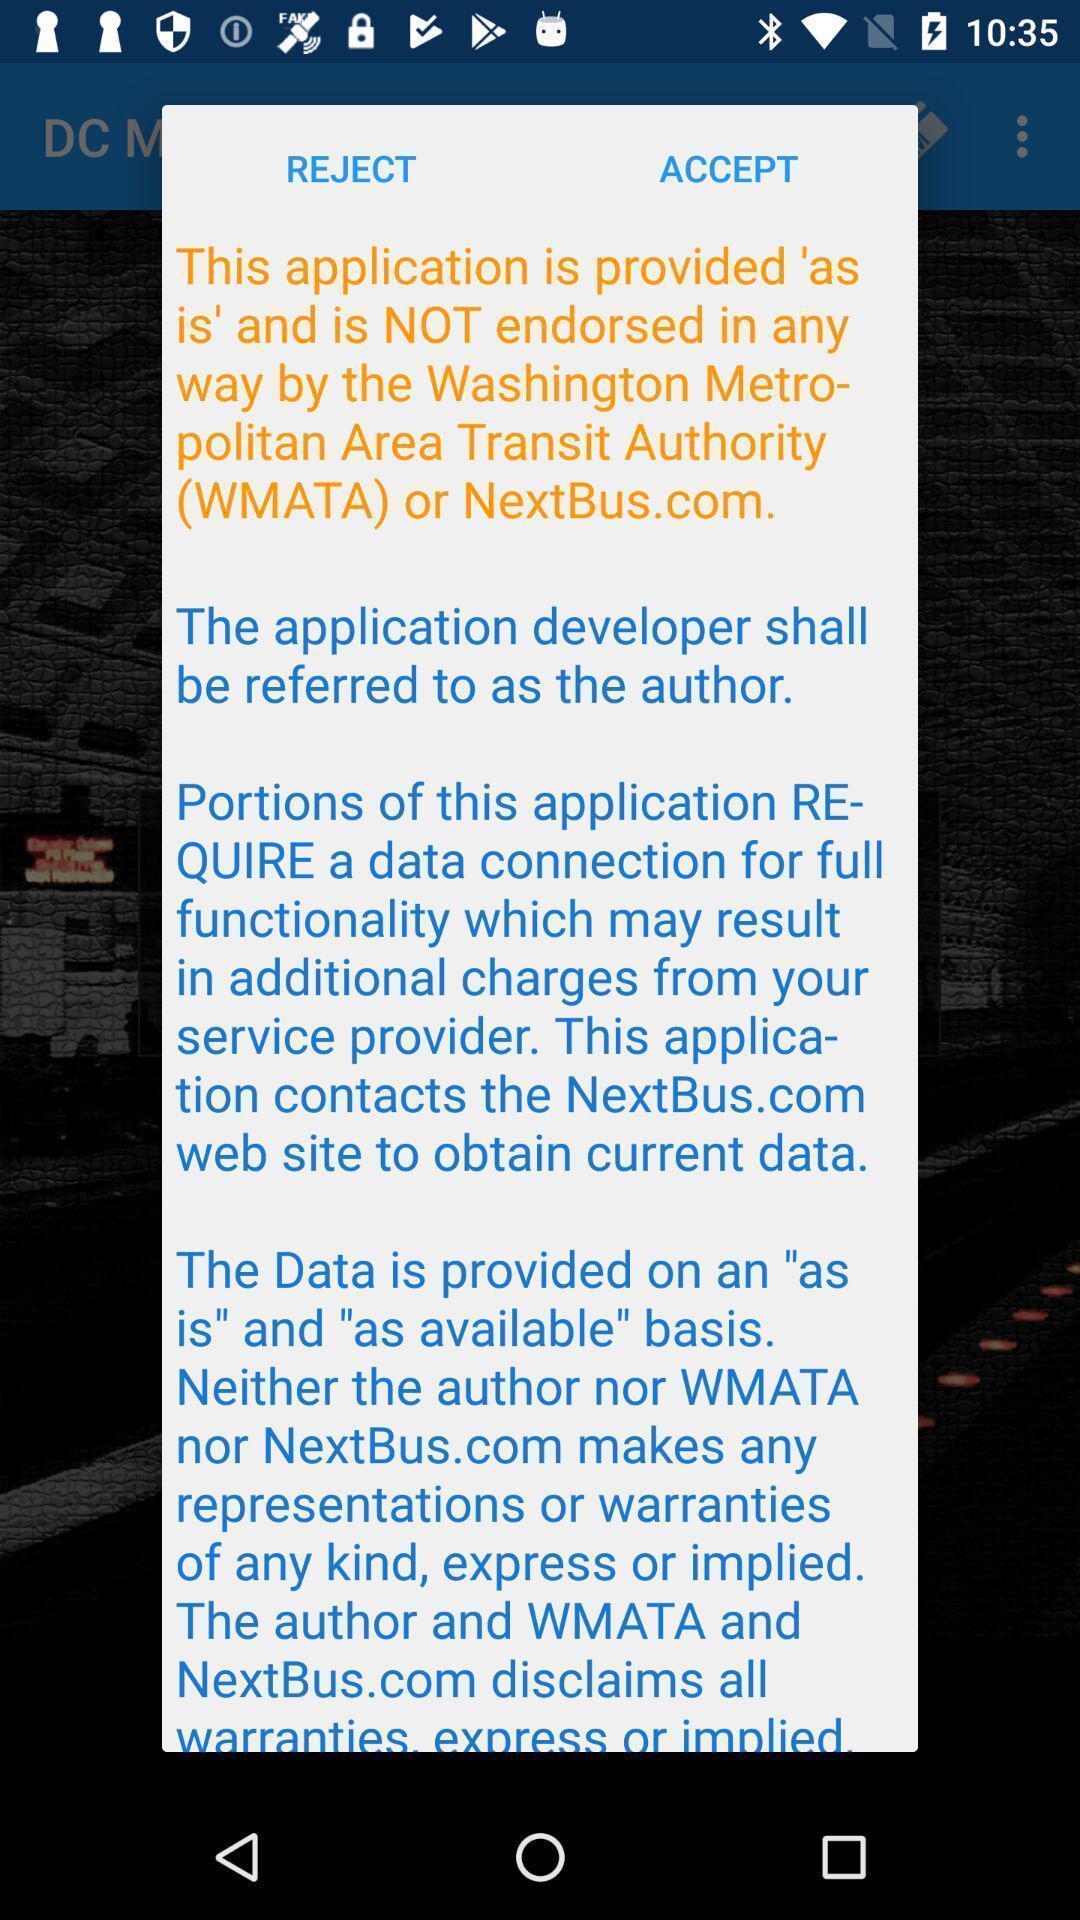Tell me what you see in this picture. Pop-up shows message. 